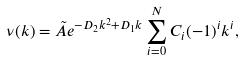Convert formula to latex. <formula><loc_0><loc_0><loc_500><loc_500>\nu ( k ) = \tilde { A } e ^ { - D _ { 2 } k ^ { 2 } + D _ { 1 } k } \sum _ { i = 0 } ^ { N } C _ { i } ( - 1 ) ^ { i } k ^ { i } ,</formula> 